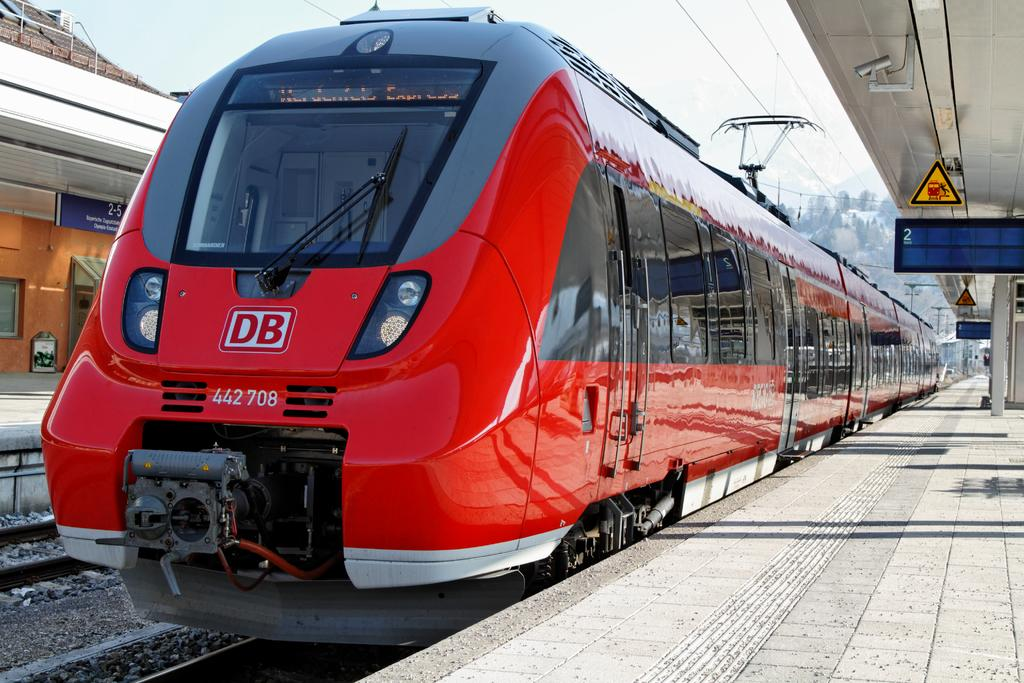<image>
Give a short and clear explanation of the subsequent image. A DB train is waiting at the station. 